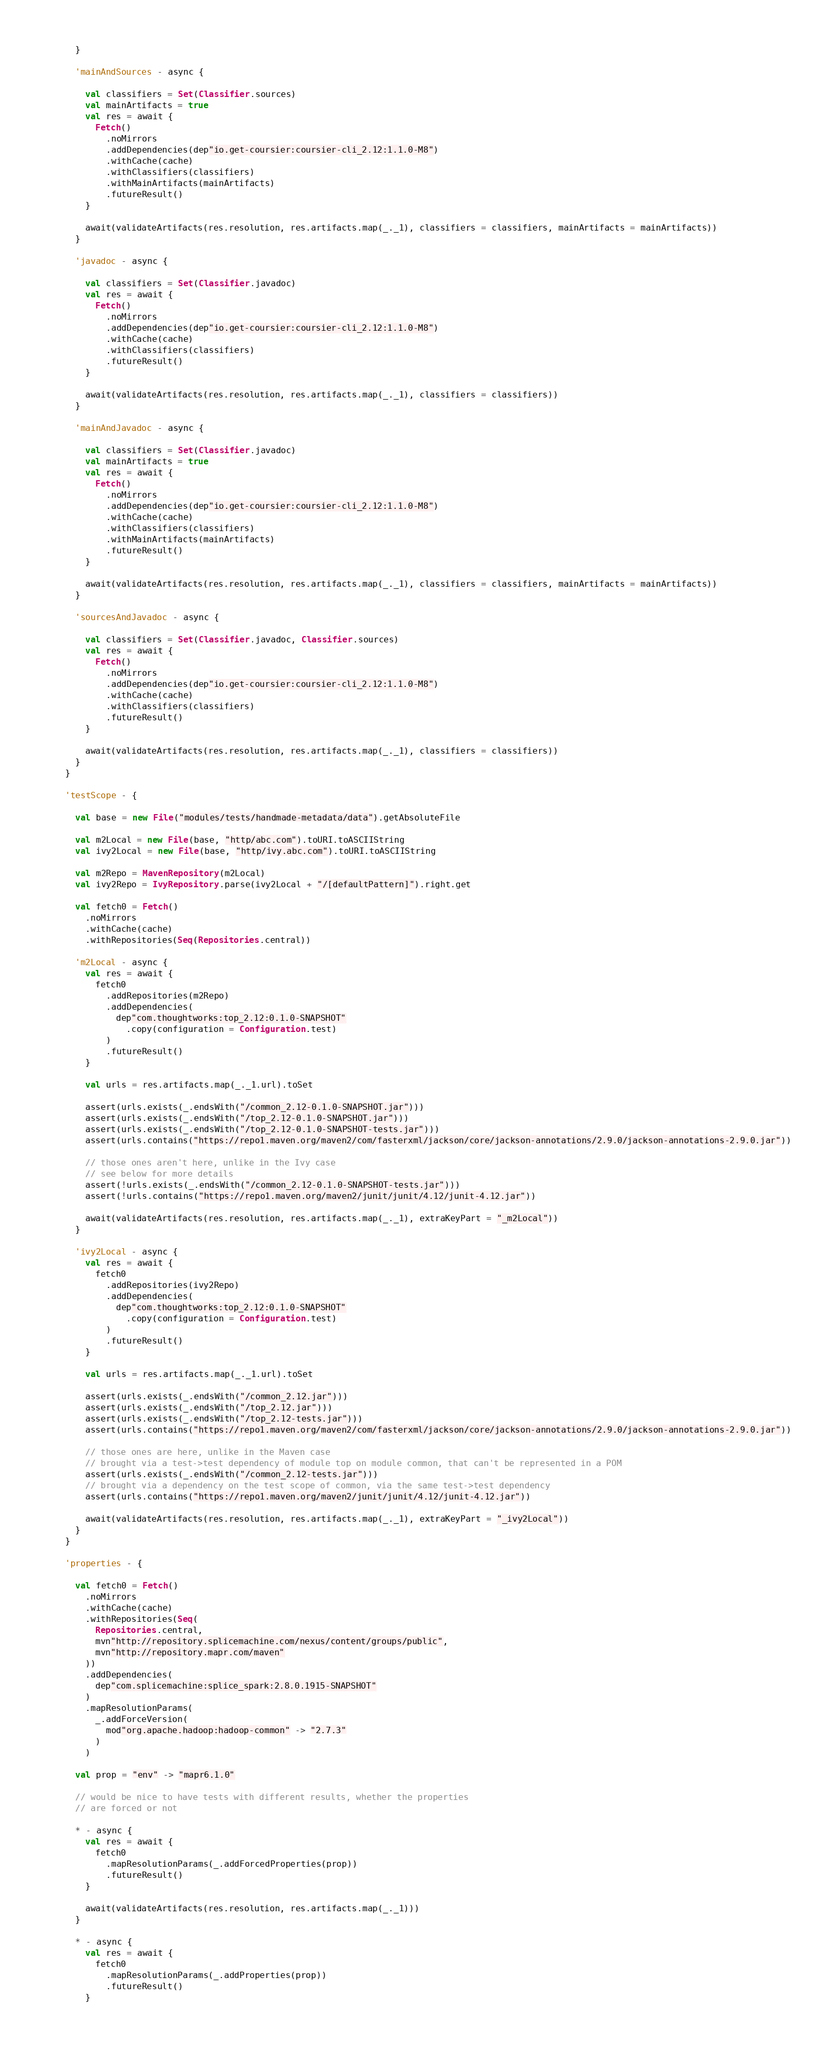<code> <loc_0><loc_0><loc_500><loc_500><_Scala_>      }

      'mainAndSources - async {

        val classifiers = Set(Classifier.sources)
        val mainArtifacts = true
        val res = await {
          Fetch()
            .noMirrors
            .addDependencies(dep"io.get-coursier:coursier-cli_2.12:1.1.0-M8")
            .withCache(cache)
            .withClassifiers(classifiers)
            .withMainArtifacts(mainArtifacts)
            .futureResult()
        }

        await(validateArtifacts(res.resolution, res.artifacts.map(_._1), classifiers = classifiers, mainArtifacts = mainArtifacts))
      }

      'javadoc - async {

        val classifiers = Set(Classifier.javadoc)
        val res = await {
          Fetch()
            .noMirrors
            .addDependencies(dep"io.get-coursier:coursier-cli_2.12:1.1.0-M8")
            .withCache(cache)
            .withClassifiers(classifiers)
            .futureResult()
        }

        await(validateArtifacts(res.resolution, res.artifacts.map(_._1), classifiers = classifiers))
      }

      'mainAndJavadoc - async {

        val classifiers = Set(Classifier.javadoc)
        val mainArtifacts = true
        val res = await {
          Fetch()
            .noMirrors
            .addDependencies(dep"io.get-coursier:coursier-cli_2.12:1.1.0-M8")
            .withCache(cache)
            .withClassifiers(classifiers)
            .withMainArtifacts(mainArtifacts)
            .futureResult()
        }

        await(validateArtifacts(res.resolution, res.artifacts.map(_._1), classifiers = classifiers, mainArtifacts = mainArtifacts))
      }

      'sourcesAndJavadoc - async {

        val classifiers = Set(Classifier.javadoc, Classifier.sources)
        val res = await {
          Fetch()
            .noMirrors
            .addDependencies(dep"io.get-coursier:coursier-cli_2.12:1.1.0-M8")
            .withCache(cache)
            .withClassifiers(classifiers)
            .futureResult()
        }

        await(validateArtifacts(res.resolution, res.artifacts.map(_._1), classifiers = classifiers))
      }
    }

    'testScope - {

      val base = new File("modules/tests/handmade-metadata/data").getAbsoluteFile

      val m2Local = new File(base, "http/abc.com").toURI.toASCIIString
      val ivy2Local = new File(base, "http/ivy.abc.com").toURI.toASCIIString

      val m2Repo = MavenRepository(m2Local)
      val ivy2Repo = IvyRepository.parse(ivy2Local + "/[defaultPattern]").right.get

      val fetch0 = Fetch()
        .noMirrors
        .withCache(cache)
        .withRepositories(Seq(Repositories.central))

      'm2Local - async {
        val res = await {
          fetch0
            .addRepositories(m2Repo)
            .addDependencies(
              dep"com.thoughtworks:top_2.12:0.1.0-SNAPSHOT"
                .copy(configuration = Configuration.test)
            )
            .futureResult()
        }

        val urls = res.artifacts.map(_._1.url).toSet

        assert(urls.exists(_.endsWith("/common_2.12-0.1.0-SNAPSHOT.jar")))
        assert(urls.exists(_.endsWith("/top_2.12-0.1.0-SNAPSHOT.jar")))
        assert(urls.exists(_.endsWith("/top_2.12-0.1.0-SNAPSHOT-tests.jar")))
        assert(urls.contains("https://repo1.maven.org/maven2/com/fasterxml/jackson/core/jackson-annotations/2.9.0/jackson-annotations-2.9.0.jar"))

        // those ones aren't here, unlike in the Ivy case
        // see below for more details
        assert(!urls.exists(_.endsWith("/common_2.12-0.1.0-SNAPSHOT-tests.jar")))
        assert(!urls.contains("https://repo1.maven.org/maven2/junit/junit/4.12/junit-4.12.jar"))

        await(validateArtifacts(res.resolution, res.artifacts.map(_._1), extraKeyPart = "_m2Local"))
      }

      'ivy2Local - async {
        val res = await {
          fetch0
            .addRepositories(ivy2Repo)
            .addDependencies(
              dep"com.thoughtworks:top_2.12:0.1.0-SNAPSHOT"
                .copy(configuration = Configuration.test)
            )
            .futureResult()
        }

        val urls = res.artifacts.map(_._1.url).toSet

        assert(urls.exists(_.endsWith("/common_2.12.jar")))
        assert(urls.exists(_.endsWith("/top_2.12.jar")))
        assert(urls.exists(_.endsWith("/top_2.12-tests.jar")))
        assert(urls.contains("https://repo1.maven.org/maven2/com/fasterxml/jackson/core/jackson-annotations/2.9.0/jackson-annotations-2.9.0.jar"))

        // those ones are here, unlike in the Maven case
        // brought via a test->test dependency of module top on module common, that can't be represented in a POM
        assert(urls.exists(_.endsWith("/common_2.12-tests.jar")))
        // brought via a dependency on the test scope of common, via the same test->test dependency
        assert(urls.contains("https://repo1.maven.org/maven2/junit/junit/4.12/junit-4.12.jar"))

        await(validateArtifacts(res.resolution, res.artifacts.map(_._1), extraKeyPart = "_ivy2Local"))
      }
    }

    'properties - {

      val fetch0 = Fetch()
        .noMirrors
        .withCache(cache)
        .withRepositories(Seq(
          Repositories.central,
          mvn"http://repository.splicemachine.com/nexus/content/groups/public",
          mvn"http://repository.mapr.com/maven"
        ))
        .addDependencies(
          dep"com.splicemachine:splice_spark:2.8.0.1915-SNAPSHOT"
        )
        .mapResolutionParams(
          _.addForceVersion(
            mod"org.apache.hadoop:hadoop-common" -> "2.7.3"
          )
        )

      val prop = "env" -> "mapr6.1.0"

      // would be nice to have tests with different results, whether the properties
      // are forced or not

      * - async {
        val res = await {
          fetch0
            .mapResolutionParams(_.addForcedProperties(prop))
            .futureResult()
        }

        await(validateArtifacts(res.resolution, res.artifacts.map(_._1)))
      }

      * - async {
        val res = await {
          fetch0
            .mapResolutionParams(_.addProperties(prop))
            .futureResult()
        }
</code> 